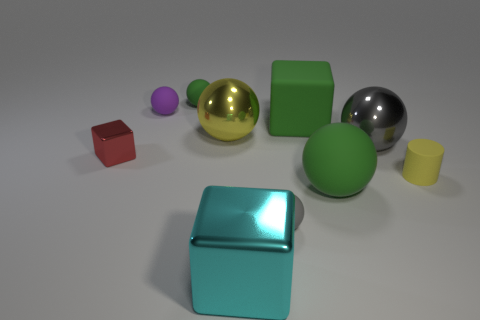What number of spheres are in front of the small metal object?
Offer a terse response. 2. What shape is the thing in front of the tiny rubber sphere that is to the right of the large cyan cube?
Offer a terse response. Cube. Is there anything else that is the same shape as the yellow matte thing?
Your response must be concise. No. Are there more tiny rubber objects to the left of the red thing than green spheres?
Offer a very short reply. No. There is a green thing to the left of the cyan metallic cube; how many rubber spheres are to the left of it?
Provide a succinct answer. 1. What is the shape of the big matte thing that is behind the big rubber thing in front of the red shiny cube that is in front of the small purple thing?
Provide a succinct answer. Cube. What is the size of the green cube?
Offer a very short reply. Large. Are there any other big spheres that have the same material as the big green ball?
Give a very brief answer. No. What is the size of the purple object that is the same shape as the yellow metal thing?
Offer a terse response. Small. Are there an equal number of red objects that are behind the tiny purple rubber ball and big gray cylinders?
Ensure brevity in your answer.  Yes. 